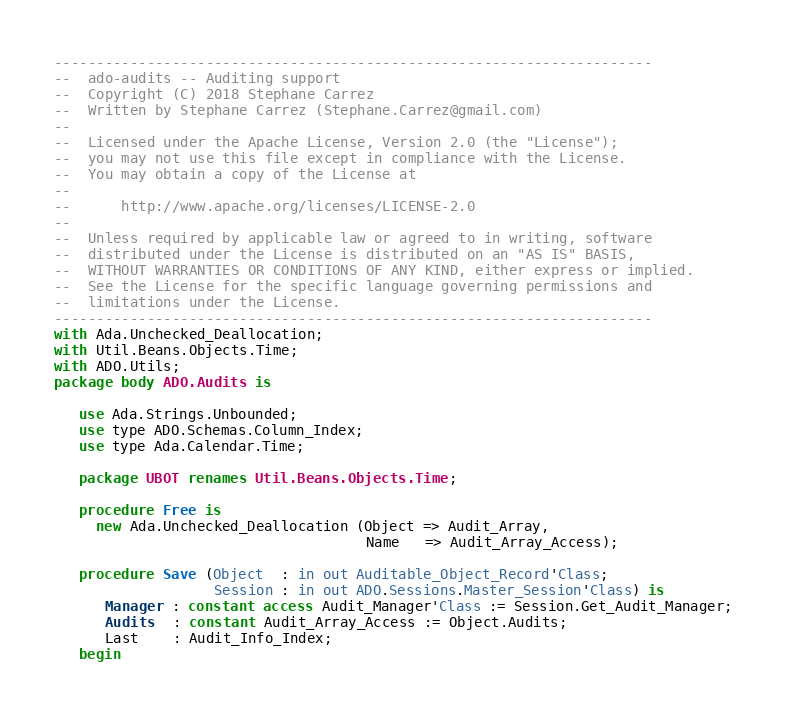Convert code to text. <code><loc_0><loc_0><loc_500><loc_500><_Ada_>-----------------------------------------------------------------------
--  ado-audits -- Auditing support
--  Copyright (C) 2018 Stephane Carrez
--  Written by Stephane Carrez (Stephane.Carrez@gmail.com)
--
--  Licensed under the Apache License, Version 2.0 (the "License");
--  you may not use this file except in compliance with the License.
--  You may obtain a copy of the License at
--
--      http://www.apache.org/licenses/LICENSE-2.0
--
--  Unless required by applicable law or agreed to in writing, software
--  distributed under the License is distributed on an "AS IS" BASIS,
--  WITHOUT WARRANTIES OR CONDITIONS OF ANY KIND, either express or implied.
--  See the License for the specific language governing permissions and
--  limitations under the License.
-----------------------------------------------------------------------
with Ada.Unchecked_Deallocation;
with Util.Beans.Objects.Time;
with ADO.Utils;
package body ADO.Audits is

   use Ada.Strings.Unbounded;
   use type ADO.Schemas.Column_Index;
   use type Ada.Calendar.Time;

   package UBOT renames Util.Beans.Objects.Time;

   procedure Free is
     new Ada.Unchecked_Deallocation (Object => Audit_Array,
                                     Name   => Audit_Array_Access);

   procedure Save (Object  : in out Auditable_Object_Record'Class;
                   Session : in out ADO.Sessions.Master_Session'Class) is
      Manager : constant access Audit_Manager'Class := Session.Get_Audit_Manager;
      Audits  : constant Audit_Array_Access := Object.Audits;
      Last    : Audit_Info_Index;
   begin</code> 